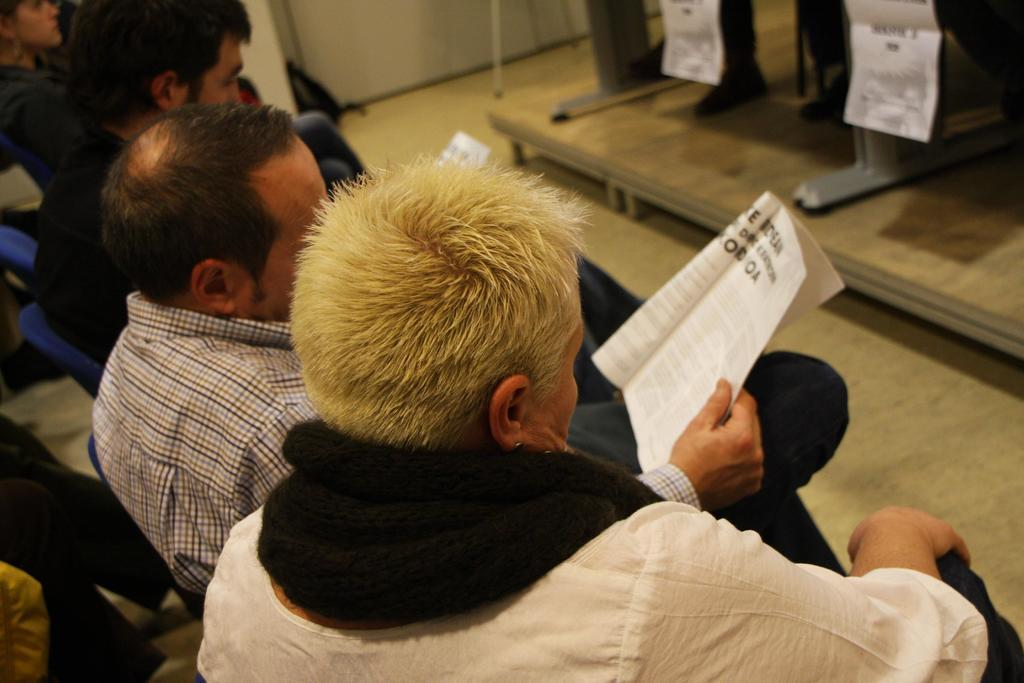What are the people in the image doing? The people in the image are sitting on chairs. What are the people wearing? The people are wearing clothes. Can you describe what one person is holding? One person is holding a book in their hand. What type of surface is visible in the image? The image shows a floor. What riddle is being whispered by the people in the image? There is no mention of a riddle or whispering in the image; the people are simply sitting on chairs and one person is holding a book. 